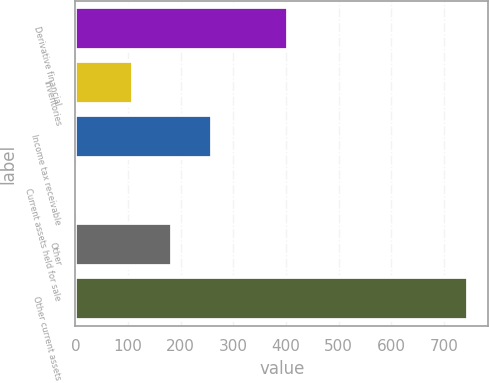Convert chart. <chart><loc_0><loc_0><loc_500><loc_500><bar_chart><fcel>Derivative financial<fcel>Inventories<fcel>Income tax receivable<fcel>Current assets held for sale<fcel>Other<fcel>Other current assets<nl><fcel>403<fcel>110<fcel>258.6<fcel>3<fcel>184.3<fcel>746<nl></chart> 